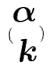Convert formula to latex. <formula><loc_0><loc_0><loc_500><loc_500>( \begin{matrix} \alpha \\ k \end{matrix} )</formula> 